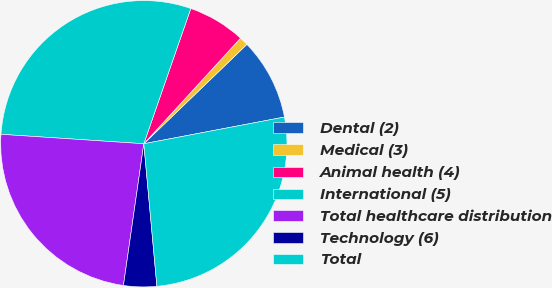Convert chart. <chart><loc_0><loc_0><loc_500><loc_500><pie_chart><fcel>Dental (2)<fcel>Medical (3)<fcel>Animal health (4)<fcel>International (5)<fcel>Total healthcare distribution<fcel>Technology (6)<fcel>Total<nl><fcel>9.22%<fcel>0.99%<fcel>6.48%<fcel>29.27%<fcel>23.78%<fcel>3.73%<fcel>26.53%<nl></chart> 